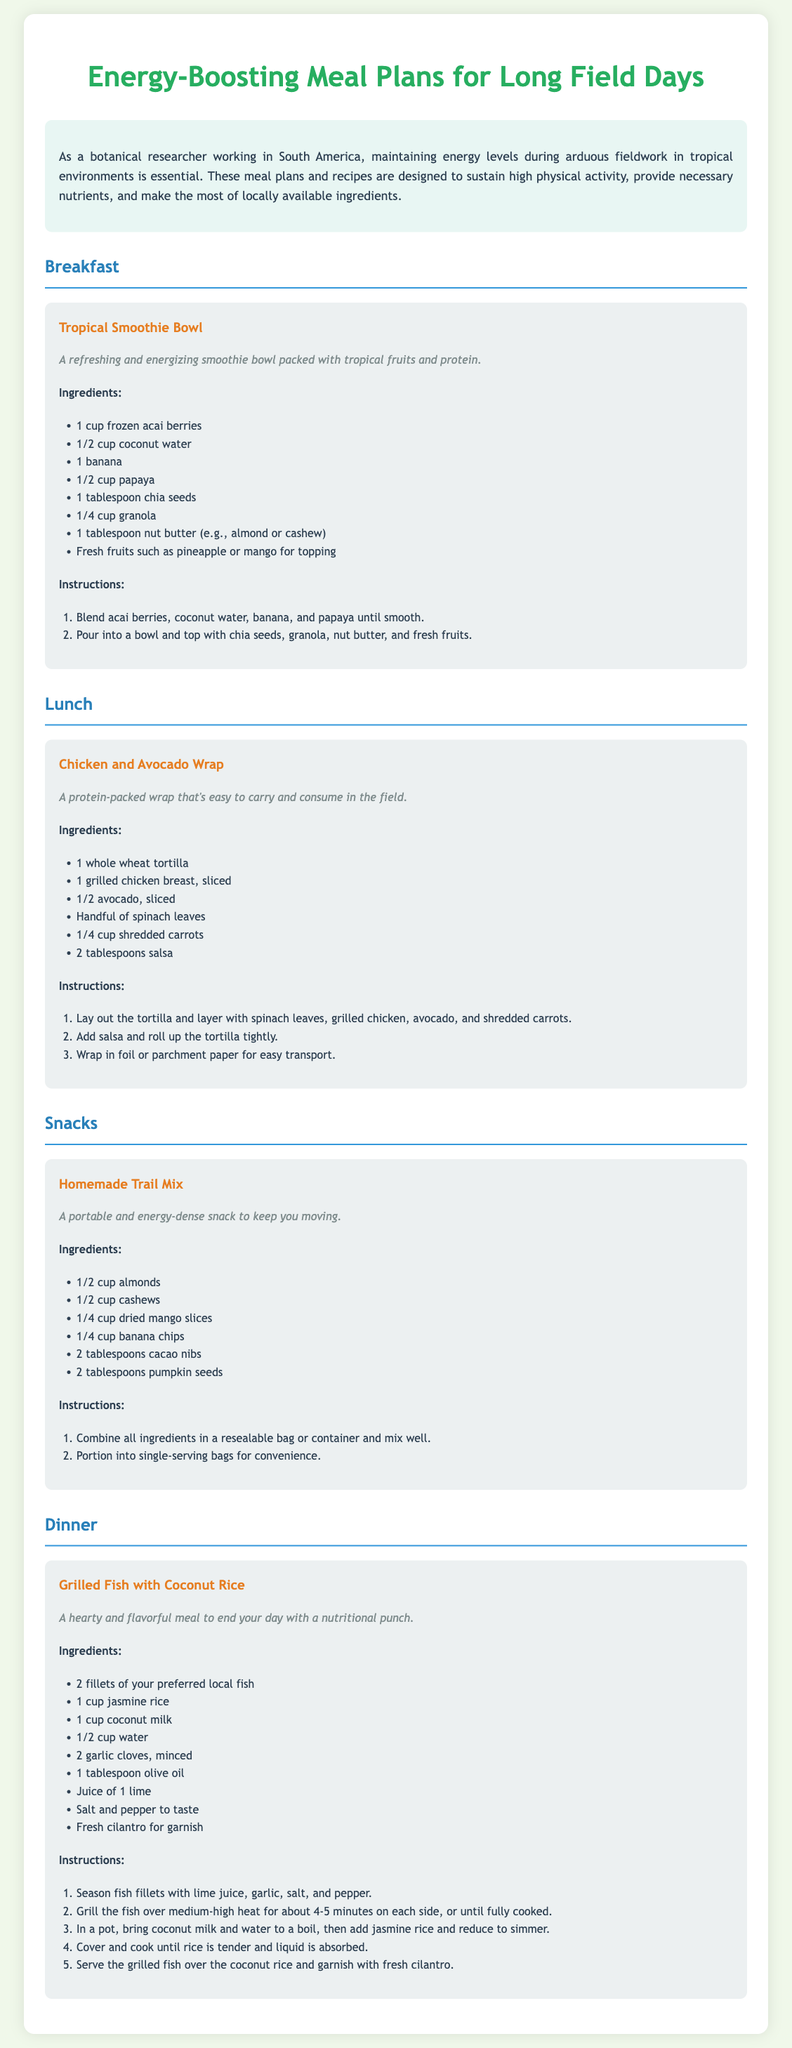What is the first meal mentioned in the meal plan? The first meal mentioned in the document is the Tropical Smoothie Bowl, which is categorized under Breakfast.
Answer: Tropical Smoothie Bowl How many ingredients are required for the Chicken and Avocado Wrap? The Chicken and Avocado Wrap has a listed total of six ingredients in the document.
Answer: 6 What is one of the main ingredients in the Tropical Smoothie Bowl? One of the main ingredients required for the Tropical Smoothie Bowl is frozen acai berries.
Answer: frozen acai berries What is the cooking time for the grilled fish in the dinner recipe? The grilling time for the fish is about 4-5 minutes on each side according to the instructions in the document.
Answer: 4-5 minutes What type of rice is used in the Grilled Fish with Coconut Rice dish? The dish specifies the use of jasmine rice.
Answer: jasmine rice How is the Homemade Trail Mix packaged for convenience? The Homemade Trail Mix is suggested to be portioned into single-serving bags for convenience.
Answer: single-serving bags Which meal is designed to be easy to carry and consume in the field? The Chicken and Avocado Wrap is specifically mentioned as being easy to carry and consume in the field.
Answer: Chicken and Avocado Wrap What is the primary source of protein in the Tropical Smoothie Bowl? The primary source of protein listed in the Tropical Smoothie Bowl is nut butter.
Answer: nut butter What fruit is used as a topping in the Tropical Smoothie Bowl? The document mentions using fresh fruits such as pineapple or mango for topping.
Answer: pineapple or mango 